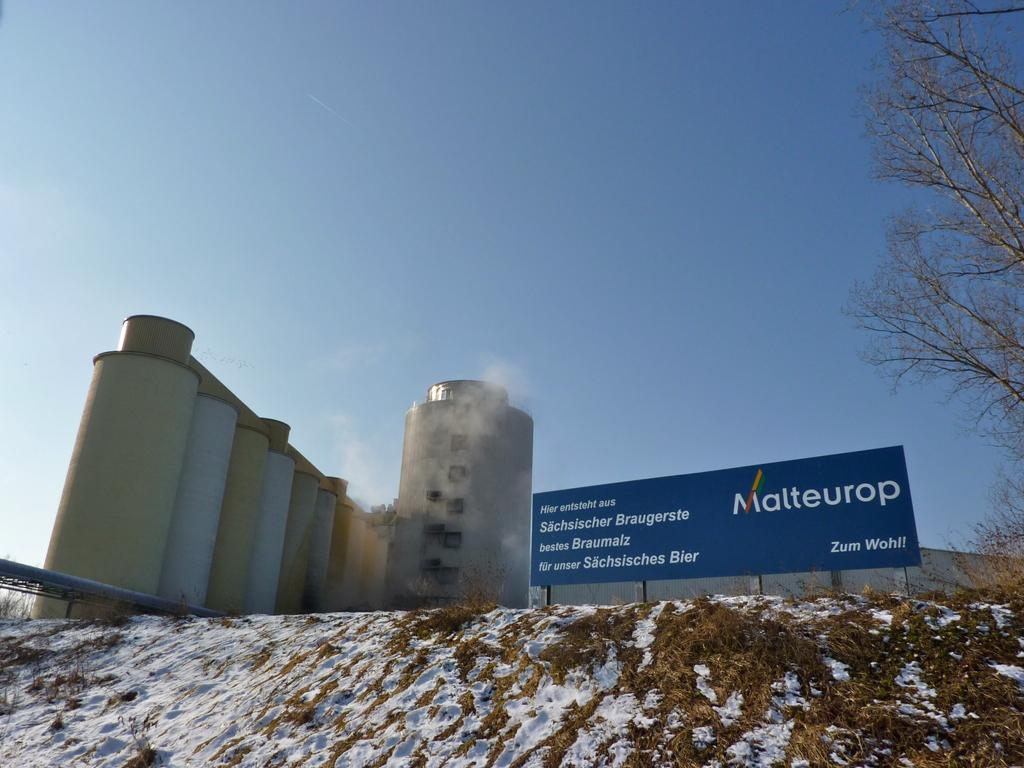Provide a one-sentence caption for the provided image. a buliding with a sign out front with Malteurop on it. 